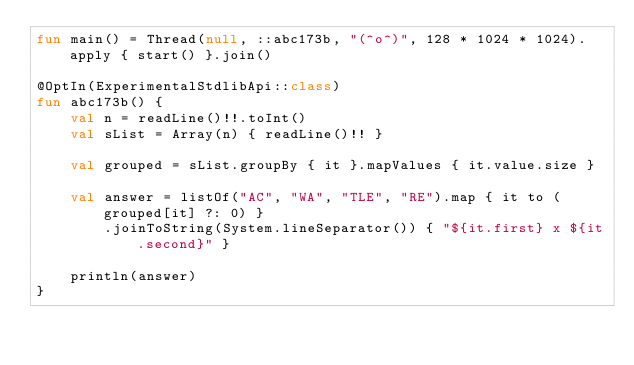<code> <loc_0><loc_0><loc_500><loc_500><_Kotlin_>fun main() = Thread(null, ::abc173b, "(^o^)", 128 * 1024 * 1024).apply { start() }.join()

@OptIn(ExperimentalStdlibApi::class)
fun abc173b() {
    val n = readLine()!!.toInt()
    val sList = Array(n) { readLine()!! }

    val grouped = sList.groupBy { it }.mapValues { it.value.size }

    val answer = listOf("AC", "WA", "TLE", "RE").map { it to (grouped[it] ?: 0) }
        .joinToString(System.lineSeparator()) { "${it.first} x ${it.second}" }

    println(answer)
}
</code> 